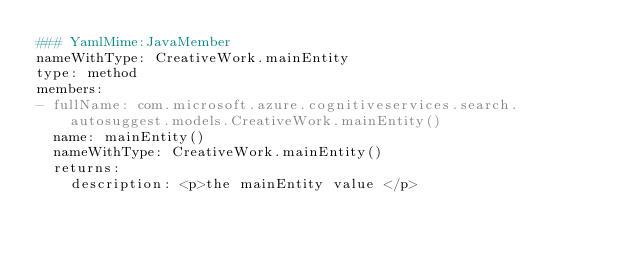Convert code to text. <code><loc_0><loc_0><loc_500><loc_500><_YAML_>### YamlMime:JavaMember
nameWithType: CreativeWork.mainEntity
type: method
members:
- fullName: com.microsoft.azure.cognitiveservices.search.autosuggest.models.CreativeWork.mainEntity()
  name: mainEntity()
  nameWithType: CreativeWork.mainEntity()
  returns:
    description: <p>the mainEntity value </p></code> 